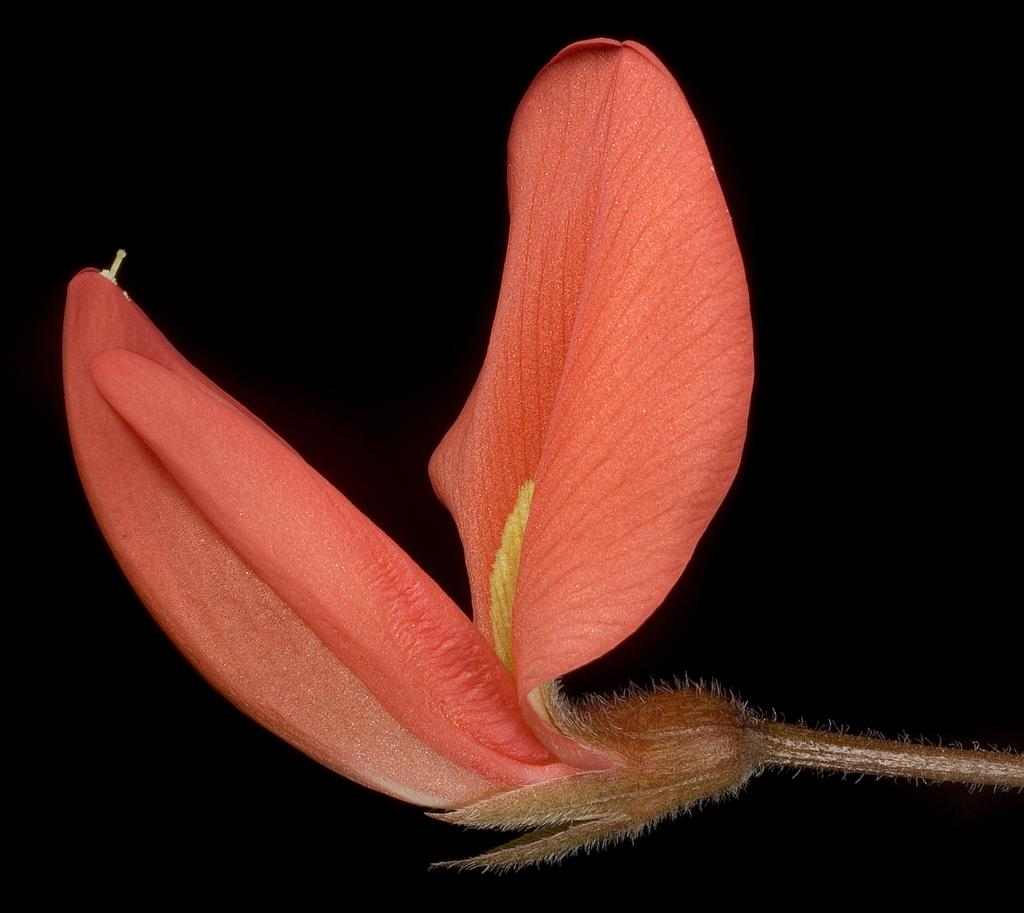What is the main subject of the image? The main subject of the image is a flower. Can you describe the color of the flower? The flower is pink. What can be seen in the background of the image? The background of the image is dark. What type of laborer is working in the background of the image? There is no laborer present in the image; it features a pink flower with a dark background. What activity is the range performing in the image? There is no range present in the image; it features a pink flower with a dark background. 